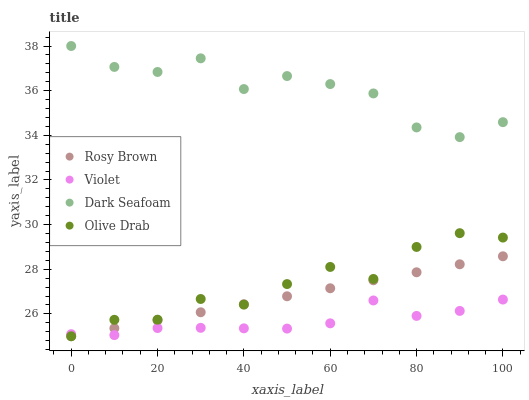Does Violet have the minimum area under the curve?
Answer yes or no. Yes. Does Dark Seafoam have the maximum area under the curve?
Answer yes or no. Yes. Does Rosy Brown have the minimum area under the curve?
Answer yes or no. No. Does Rosy Brown have the maximum area under the curve?
Answer yes or no. No. Is Rosy Brown the smoothest?
Answer yes or no. Yes. Is Dark Seafoam the roughest?
Answer yes or no. Yes. Is Olive Drab the smoothest?
Answer yes or no. No. Is Olive Drab the roughest?
Answer yes or no. No. Does Rosy Brown have the lowest value?
Answer yes or no. Yes. Does Violet have the lowest value?
Answer yes or no. No. Does Dark Seafoam have the highest value?
Answer yes or no. Yes. Does Rosy Brown have the highest value?
Answer yes or no. No. Is Rosy Brown less than Dark Seafoam?
Answer yes or no. Yes. Is Dark Seafoam greater than Rosy Brown?
Answer yes or no. Yes. Does Olive Drab intersect Rosy Brown?
Answer yes or no. Yes. Is Olive Drab less than Rosy Brown?
Answer yes or no. No. Is Olive Drab greater than Rosy Brown?
Answer yes or no. No. Does Rosy Brown intersect Dark Seafoam?
Answer yes or no. No. 